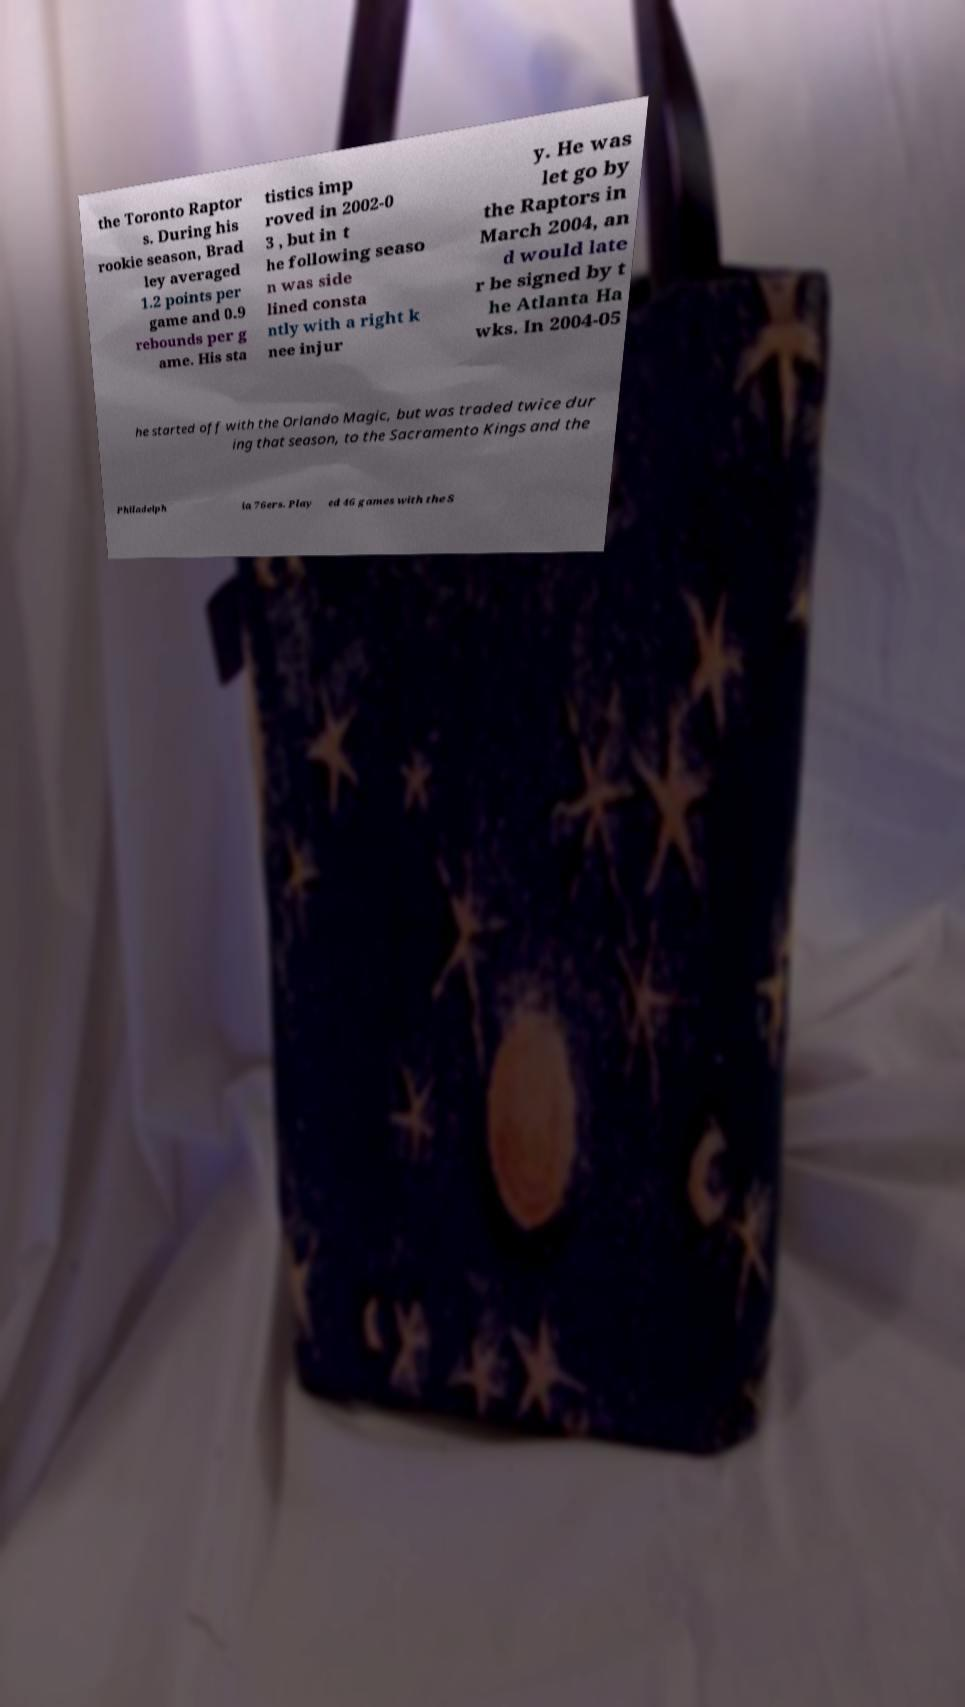Can you accurately transcribe the text from the provided image for me? the Toronto Raptor s. During his rookie season, Brad ley averaged 1.2 points per game and 0.9 rebounds per g ame. His sta tistics imp roved in 2002-0 3 , but in t he following seaso n was side lined consta ntly with a right k nee injur y. He was let go by the Raptors in March 2004, an d would late r be signed by t he Atlanta Ha wks. In 2004-05 he started off with the Orlando Magic, but was traded twice dur ing that season, to the Sacramento Kings and the Philadelph ia 76ers. Play ed 46 games with the S 